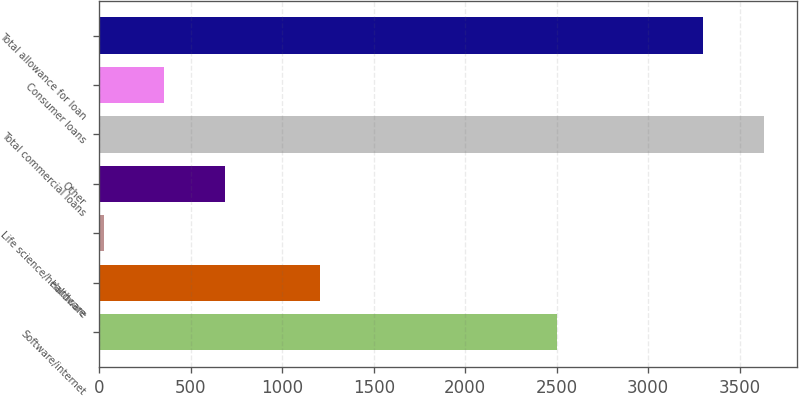<chart> <loc_0><loc_0><loc_500><loc_500><bar_chart><fcel>Software/internet<fcel>Hardware<fcel>Life science/healthcare<fcel>Other<fcel>Total commercial loans<fcel>Consumer loans<fcel>Total allowance for loan<nl><fcel>2501<fcel>1204<fcel>23<fcel>687.8<fcel>3631.4<fcel>355.4<fcel>3299<nl></chart> 